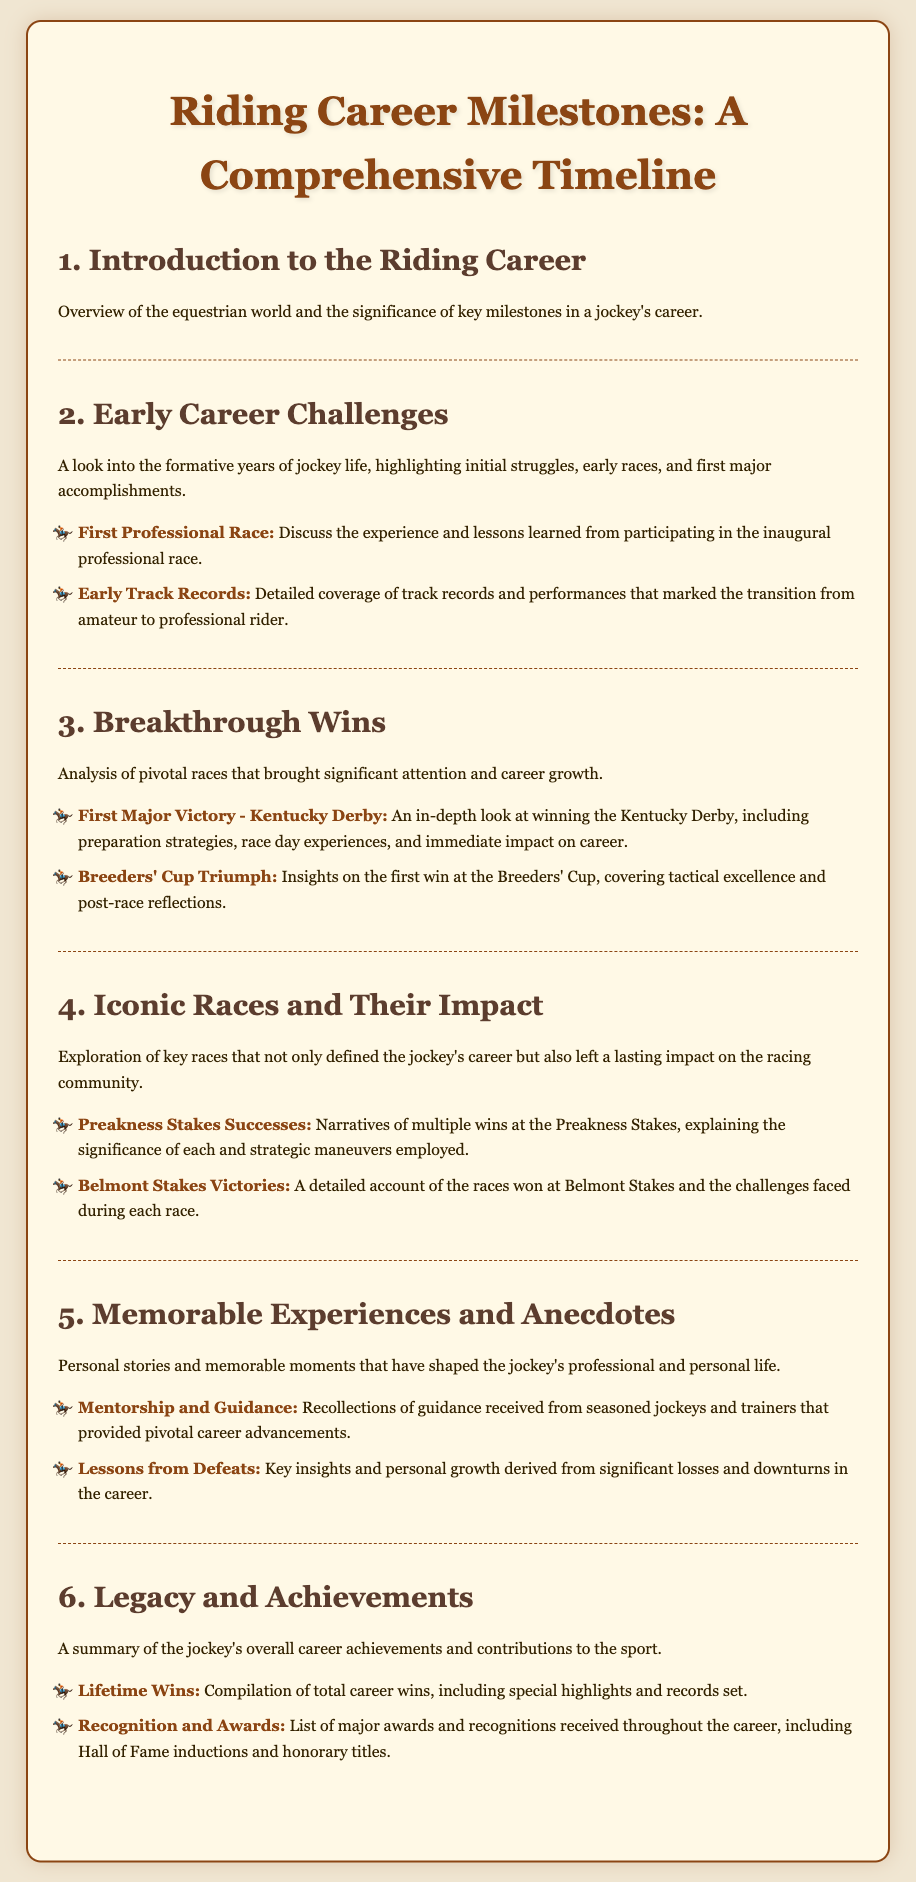what is the title of the syllabus? The title of the syllabus is presented at the top of the document.
Answer: Riding Career Milestones: A Comprehensive Timeline what is covered in the first unit? The first unit provides an overview of the equestrian world and the significance of key milestones in a jockey's career.
Answer: Introduction to the Riding Career what major victory is discussed in the third unit? The third unit discusses the first major victory, which is a significant win in a key race.
Answer: Kentucky Derby what is highlighted in the fifth unit? The fifth unit highlights personal stories and memorable moments that have impacted the jockey's professional and personal life.
Answer: Memorable Experiences and Anecdotes how many topics are discussed in the fourth unit? The fourth unit contains two topics that pertain to key races in the jockey's career.
Answer: 2 which race is mentioned in the second unit's early career challenges? The second unit talks about the first professional race experience.
Answer: First Professional Race what lessons are derived from losses according to the syllabus? The syllabus states that key insights and personal growth are derived from significant losses and downturns in the career.
Answer: Lessons from Defeats what is mentioned in the last unit under recognition? The last unit lists major awards and recognitions received throughout the jockey's career.
Answer: Recognition and Awards what is the theme of the fourth unit? The theme of the fourth unit explores key races that defined the jockey's career.
Answer: Iconic Races and Their Impact 